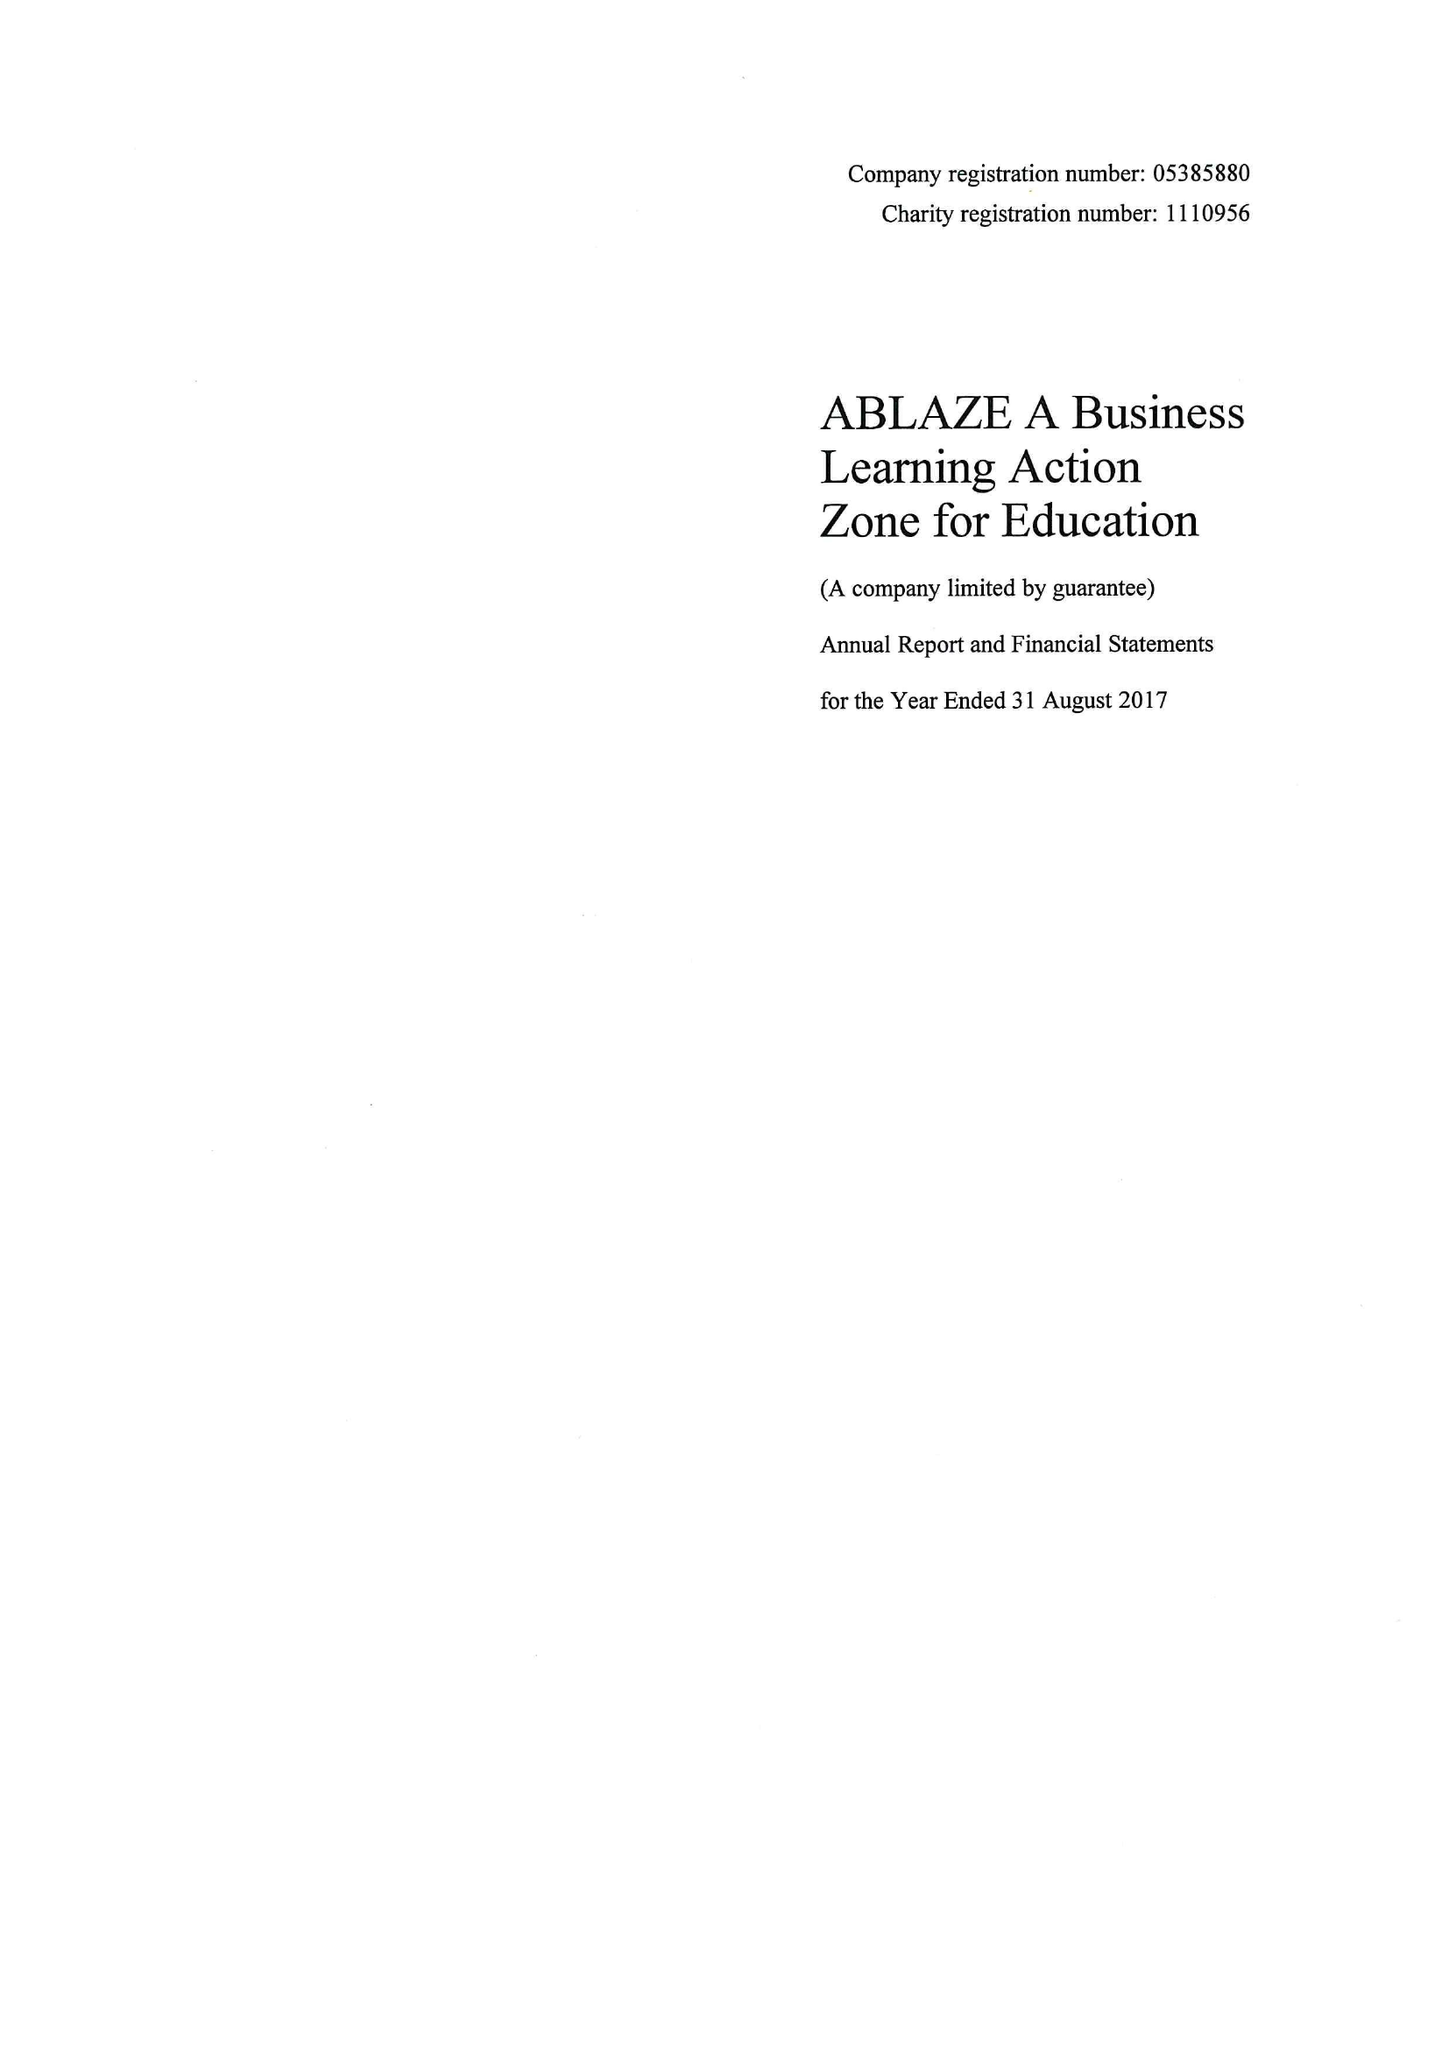What is the value for the address__post_town?
Answer the question using a single word or phrase. BRISTOL 